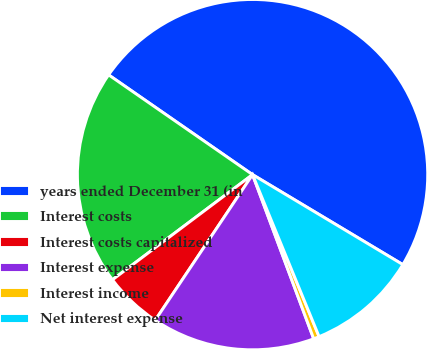<chart> <loc_0><loc_0><loc_500><loc_500><pie_chart><fcel>years ended December 31 (in<fcel>Interest costs<fcel>Interest costs capitalized<fcel>Interest expense<fcel>Interest income<fcel>Net interest expense<nl><fcel>48.93%<fcel>19.89%<fcel>5.37%<fcel>15.05%<fcel>0.53%<fcel>10.21%<nl></chart> 